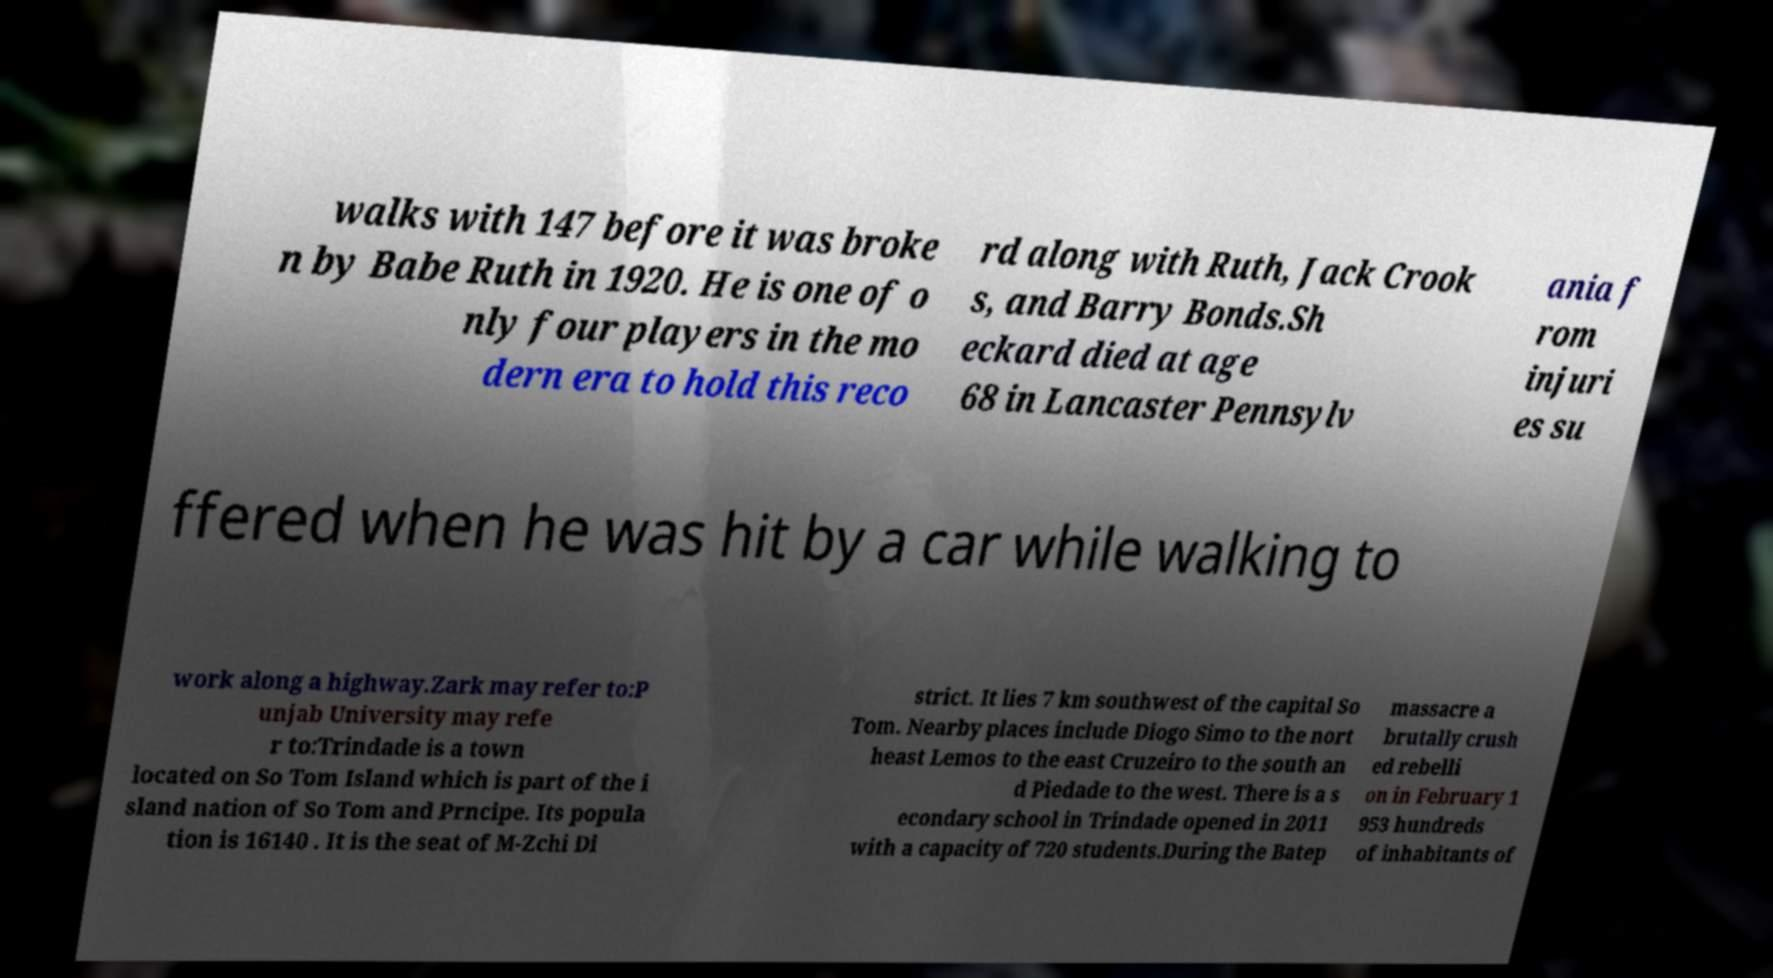Please read and relay the text visible in this image. What does it say? walks with 147 before it was broke n by Babe Ruth in 1920. He is one of o nly four players in the mo dern era to hold this reco rd along with Ruth, Jack Crook s, and Barry Bonds.Sh eckard died at age 68 in Lancaster Pennsylv ania f rom injuri es su ffered when he was hit by a car while walking to work along a highway.Zark may refer to:P unjab University may refe r to:Trindade is a town located on So Tom Island which is part of the i sland nation of So Tom and Prncipe. Its popula tion is 16140 . It is the seat of M-Zchi Di strict. It lies 7 km southwest of the capital So Tom. Nearby places include Diogo Simo to the nort heast Lemos to the east Cruzeiro to the south an d Piedade to the west. There is a s econdary school in Trindade opened in 2011 with a capacity of 720 students.During the Batep massacre a brutally crush ed rebelli on in February 1 953 hundreds of inhabitants of 